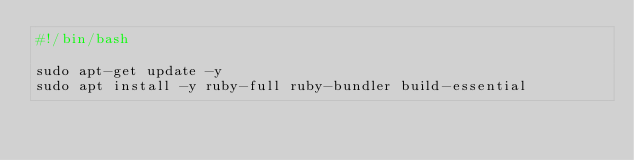Convert code to text. <code><loc_0><loc_0><loc_500><loc_500><_Bash_>#!/bin/bash

sudo apt-get update -y
sudo apt install -y ruby-full ruby-bundler build-essential
</code> 